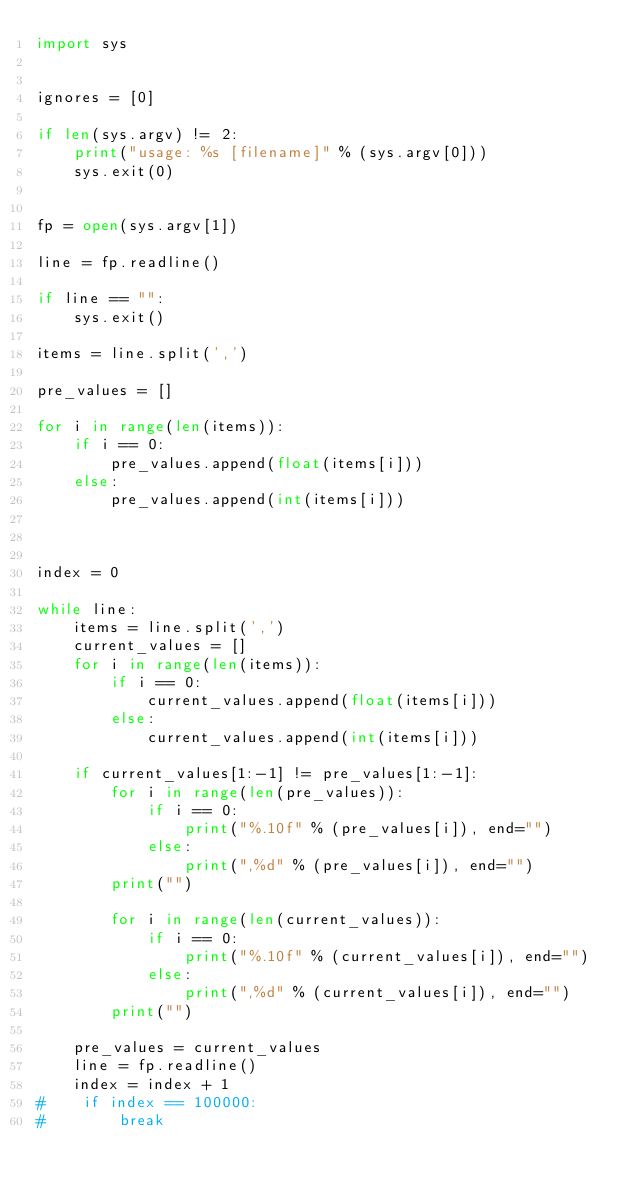<code> <loc_0><loc_0><loc_500><loc_500><_Python_>import sys


ignores = [0]

if len(sys.argv) != 2:
    print("usage: %s [filename]" % (sys.argv[0]))
    sys.exit(0)


fp = open(sys.argv[1])

line = fp.readline()

if line == "":
    sys.exit()

items = line.split(',')

pre_values = []

for i in range(len(items)):
    if i == 0:
        pre_values.append(float(items[i]))
    else:
        pre_values.append(int(items[i]))
        


index = 0

while line:
    items = line.split(',')
    current_values = []
    for i in range(len(items)):
        if i == 0:
            current_values.append(float(items[i]))
        else:
            current_values.append(int(items[i]))
            
    if current_values[1:-1] != pre_values[1:-1]:
        for i in range(len(pre_values)):
            if i == 0:
                print("%.10f" % (pre_values[i]), end="")
            else:
                print(",%d" % (pre_values[i]), end="")
        print("")

        for i in range(len(current_values)):
            if i == 0:
                print("%.10f" % (current_values[i]), end="")
            else:
                print(",%d" % (current_values[i]), end="")
        print("")
        
    pre_values = current_values
    line = fp.readline()
    index = index + 1
#    if index == 100000:
#        break

    
</code> 